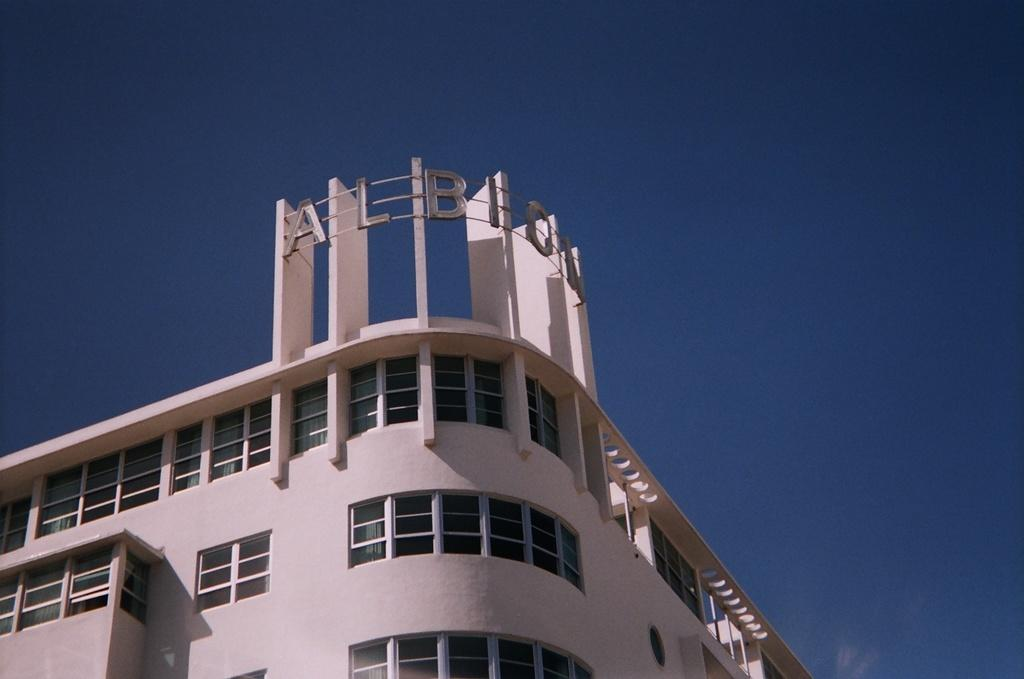What type of structure is present in the image? There is a building in the image. What information can be found on the building? The name of the building is visible on top of it. What part of the natural environment is visible in the image? The sky is visible in the image. What type of silver food can be seen on the copy of the building in the image? There is no silver food or copy of the building present in the image. 